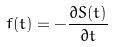Convert formula to latex. <formula><loc_0><loc_0><loc_500><loc_500>f ( t ) = - \frac { \partial S ( t ) } { \partial t }</formula> 